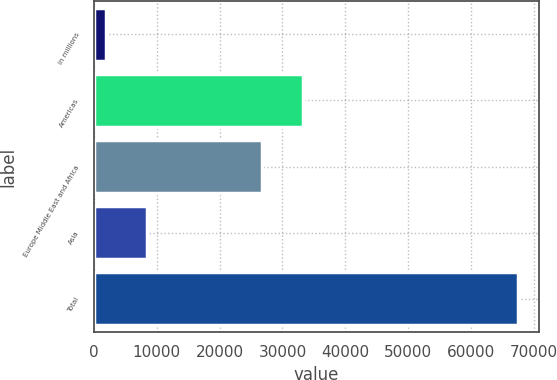Convert chart to OTSL. <chart><loc_0><loc_0><loc_500><loc_500><bar_chart><fcel>in millions<fcel>Americas<fcel>Europe Middle East and Africa<fcel>Asia<fcel>Total<nl><fcel>2012<fcel>33278.2<fcel>26739<fcel>8551.2<fcel>67404<nl></chart> 